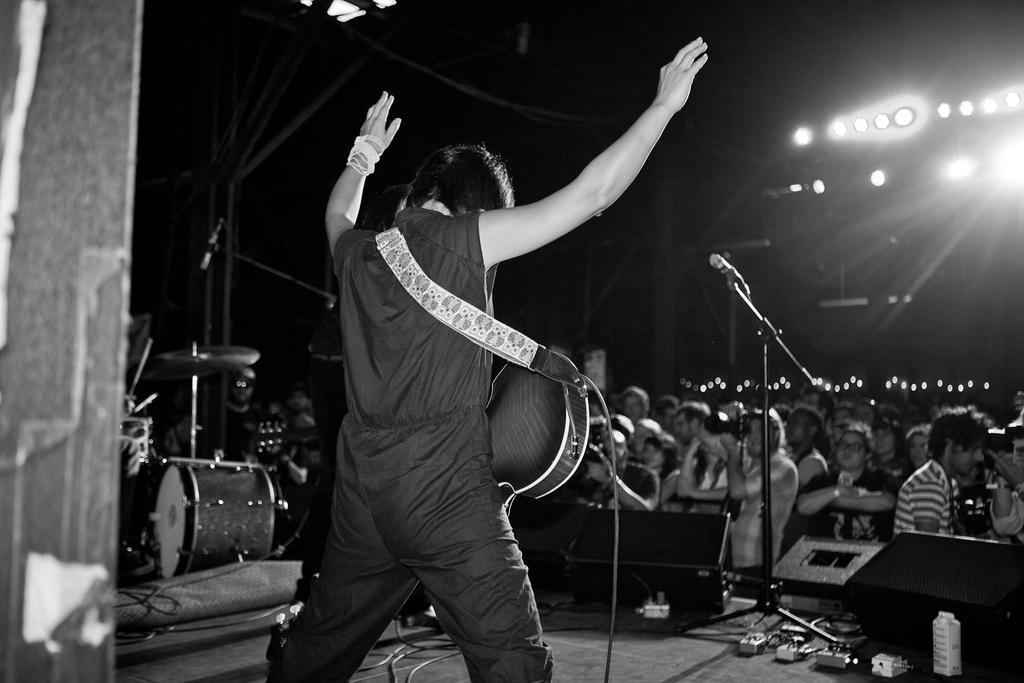Please provide a concise description of this image. There is a man standing on the floor holding a guitar across his shoulders and lifting his hands in the air. There is a microphone on the stage. And there are some drums on the left side. In the down there are some people enjoying the concert. There are some lights in the background. 